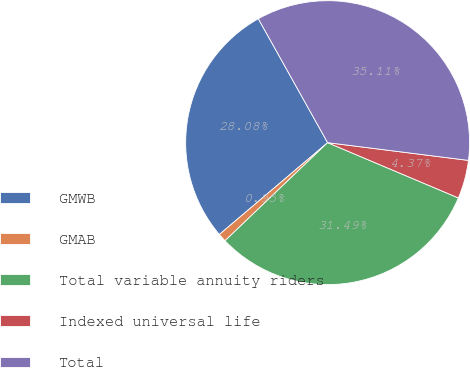Convert chart to OTSL. <chart><loc_0><loc_0><loc_500><loc_500><pie_chart><fcel>GMWB<fcel>GMAB<fcel>Total variable annuity riders<fcel>Indexed universal life<fcel>Total<nl><fcel>28.08%<fcel>0.95%<fcel>31.49%<fcel>4.37%<fcel>35.11%<nl></chart> 